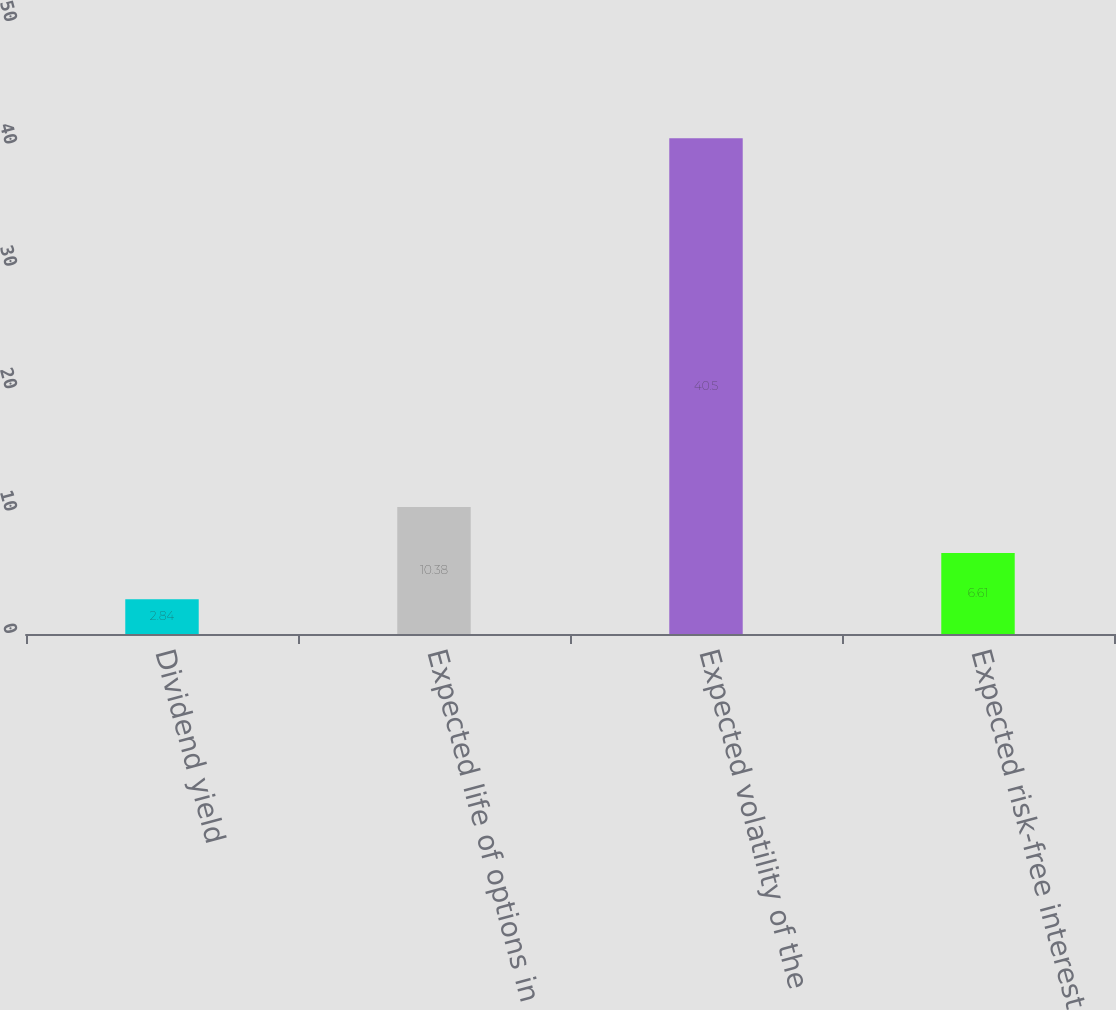Convert chart to OTSL. <chart><loc_0><loc_0><loc_500><loc_500><bar_chart><fcel>Dividend yield<fcel>Expected life of options in<fcel>Expected volatility of the<fcel>Expected risk-free interest<nl><fcel>2.84<fcel>10.38<fcel>40.5<fcel>6.61<nl></chart> 